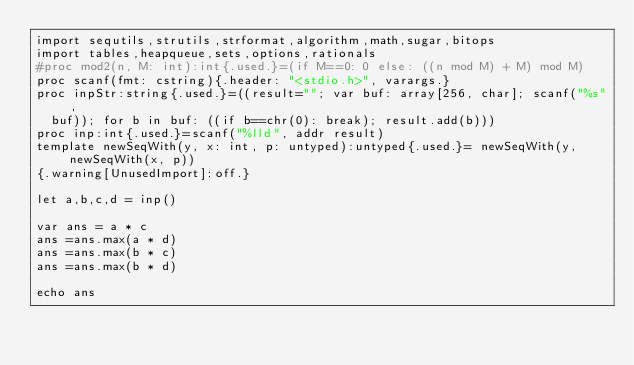<code> <loc_0><loc_0><loc_500><loc_500><_Nim_>import sequtils,strutils,strformat,algorithm,math,sugar,bitops
import tables,heapqueue,sets,options,rationals
#proc mod2(n, M: int):int{.used.}=(if M==0: 0 else: ((n mod M) + M) mod M)
proc scanf(fmt: cstring){.header: "<stdio.h>", varargs.}
proc inpStr:string{.used.}=((result=""; var buf: array[256, char]; scanf("%s",
  buf)); for b in buf: ((if b==chr(0): break); result.add(b)))
proc inp:int{.used.}=scanf("%lld", addr result)
template newSeqWith(y, x: int, p: untyped):untyped{.used.}= newSeqWith(y, newSeqWith(x, p))
{.warning[UnusedImport]:off.}

let a,b,c,d = inp()

var ans = a * c
ans =ans.max(a * d)
ans =ans.max(b * c)
ans =ans.max(b * d)

echo ans
</code> 